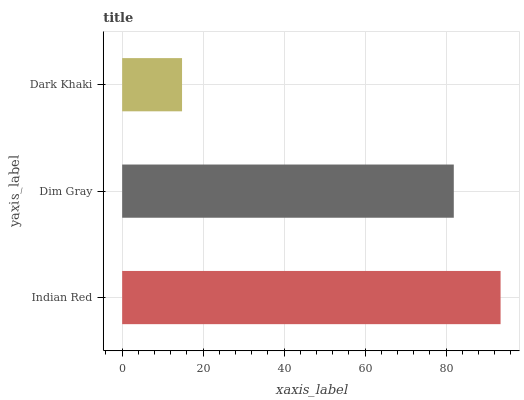Is Dark Khaki the minimum?
Answer yes or no. Yes. Is Indian Red the maximum?
Answer yes or no. Yes. Is Dim Gray the minimum?
Answer yes or no. No. Is Dim Gray the maximum?
Answer yes or no. No. Is Indian Red greater than Dim Gray?
Answer yes or no. Yes. Is Dim Gray less than Indian Red?
Answer yes or no. Yes. Is Dim Gray greater than Indian Red?
Answer yes or no. No. Is Indian Red less than Dim Gray?
Answer yes or no. No. Is Dim Gray the high median?
Answer yes or no. Yes. Is Dim Gray the low median?
Answer yes or no. Yes. Is Dark Khaki the high median?
Answer yes or no. No. Is Indian Red the low median?
Answer yes or no. No. 